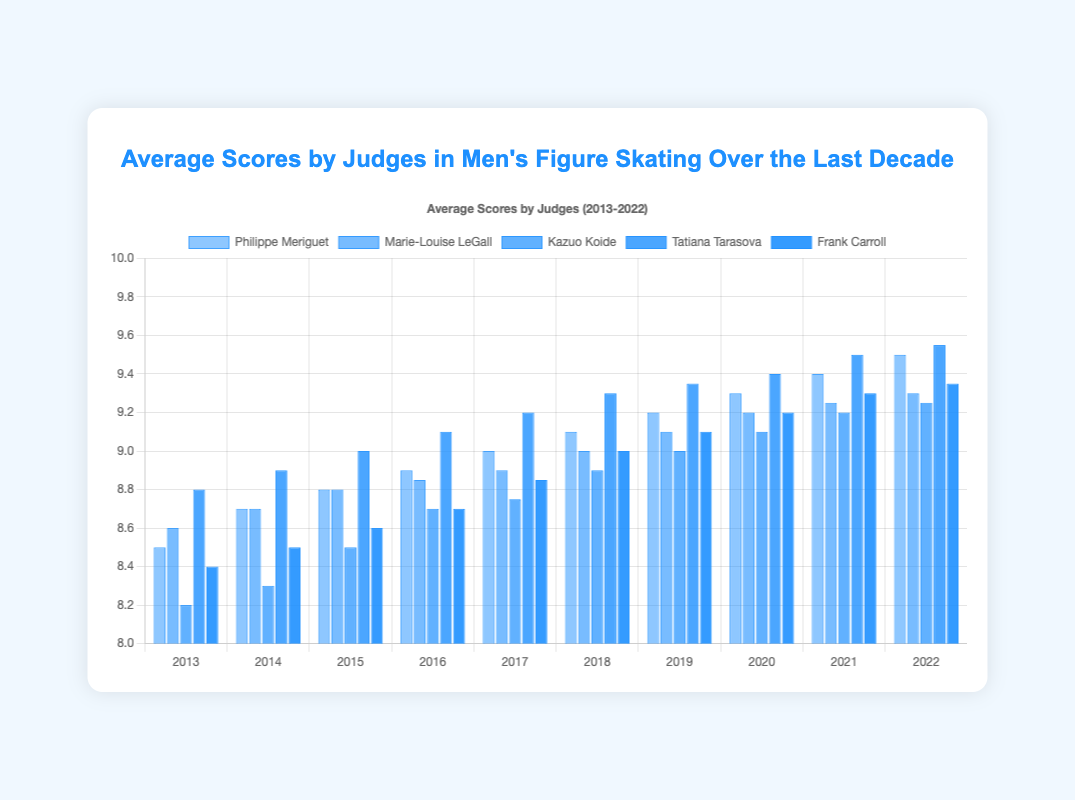What is the average score given by Tatiana Tarasova in 2020? The bar representing Tatiana Tarasova for the year 2020 shows an average score of 9.4.
Answer: 9.4 Among the five judges, who gave the highest average score in 2022? Look at the heights of the blue bars for each judge in 2022. Tatiana Tarasova has the tallest bar.
Answer: Tatiana Tarasova Compare the average scores given by Philippe Meriguet and Frank Carroll in 2017. Who gave a higher score? Refer to the height of the bars in 2017 for both judges. Philippe Meriguet gave a score of 9.0, while Frank Carroll gave a score of 8.85.
Answer: Philippe Meriguet How does Kazuo Koide's average score change from 2013 to 2022? Analyze the height of Kazuo Koide's bars from 2013 to 2022. The score increases steadily from 8.2 in 2013 to 9.25 in 2022.
Answer: Increases What is the difference in average scores between Philippe Meriguet and Marie-Louise LeGall in 2016? From the bars for 2016, Philippe Meriguet scored 8.9 and Marie-Louise LeGall scored 8.85. The difference is 8.9 - 8.85.
Answer: 0.05 What is the average score of Marie-Louise LeGall over the years 2013 and 2014? The scores are 8.6 in 2013 and 8.7 in 2014. Sum these up and divide by 2: (8.6 + 8.7) / 2 = 8.65.
Answer: 8.65 Which judge's scores in 2017 are closest to 9? Compare each judge's bar height for 2017 to the value 9. Philippe Meriguet and Tatiana Tarasova both gave scores of 9.0.
Answer: Philippe Meriguet and Tatiana Tarasova Determine the judge with the most consistent scoring pattern from 2013 to 2022. Consistency implies similar scores each year. Examine the height changes in each judge's bars over the years. Marie-Louise LeGall's scores have smaller yearly increments.
Answer: Marie-Louise LeGall What trends can you observe in the average scores given by Frank Carroll from 2013 to 2022? Observe the height of Frank Carroll's bars. The scores rise from 8.4 in 2013 to 9.35 in 2022, showing a general upward trend.
Answer: Increasing trend 